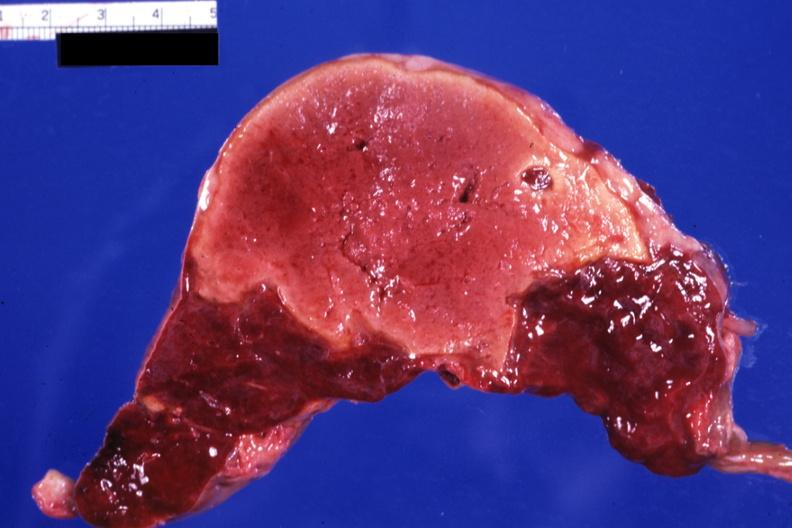s acrocyanosis present?
Answer the question using a single word or phrase. No 